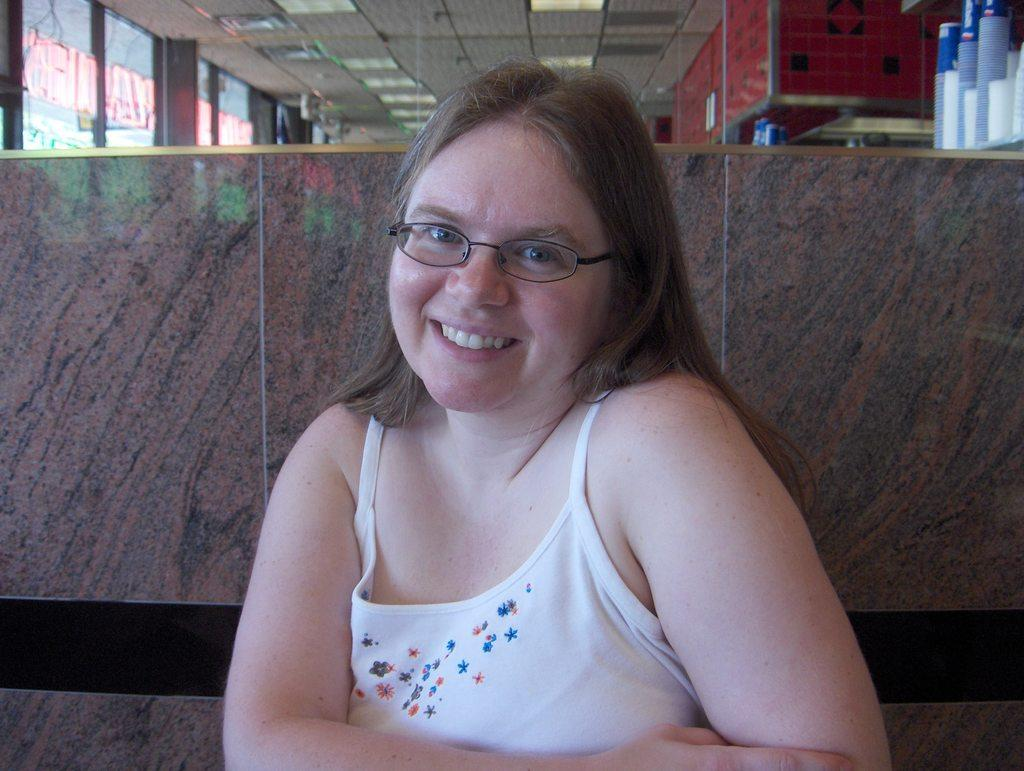Who is present in the image? There is a woman in the image. What is the woman's expression? The woman is smiling. Where are the glasses located in the image? The glasses are at the right top of the image. What can be seen in the background of the image? There is glass visible in the background of the image. What is located at the top of the image? There are lights at the top of the image. What type of street can be seen in the image? There is no street present in the image. Does the woman in the image express any hate towards someone or something? The woman's expression is a smile, and there is no indication of hate in the image. 